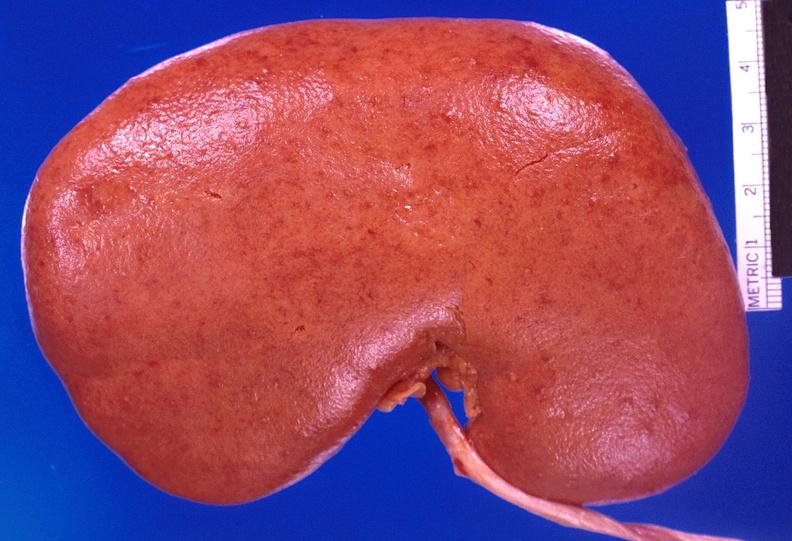does disease show kidney, candida abscesses?
Answer the question using a single word or phrase. No 